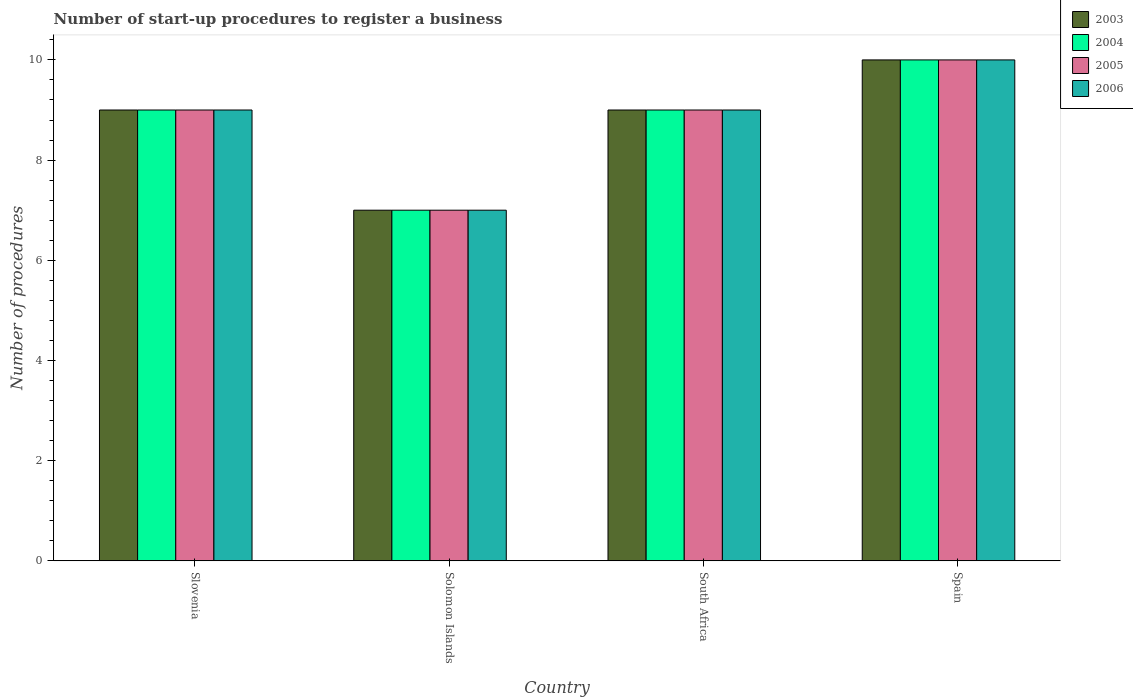How many different coloured bars are there?
Provide a succinct answer. 4. Are the number of bars per tick equal to the number of legend labels?
Your response must be concise. Yes. Are the number of bars on each tick of the X-axis equal?
Offer a terse response. Yes. How many bars are there on the 3rd tick from the left?
Your answer should be compact. 4. How many bars are there on the 2nd tick from the right?
Offer a very short reply. 4. What is the label of the 1st group of bars from the left?
Keep it short and to the point. Slovenia. In which country was the number of procedures required to register a business in 2003 maximum?
Provide a succinct answer. Spain. In which country was the number of procedures required to register a business in 2003 minimum?
Provide a short and direct response. Solomon Islands. What is the difference between the number of procedures required to register a business in 2005 in South Africa and the number of procedures required to register a business in 2006 in Solomon Islands?
Provide a succinct answer. 2. What is the average number of procedures required to register a business in 2004 per country?
Provide a succinct answer. 8.75. What is the difference between the number of procedures required to register a business of/in 2003 and number of procedures required to register a business of/in 2005 in South Africa?
Keep it short and to the point. 0. In how many countries, is the number of procedures required to register a business in 2006 greater than 7.6?
Provide a succinct answer. 3. What is the ratio of the number of procedures required to register a business in 2006 in Slovenia to that in South Africa?
Give a very brief answer. 1. Is the difference between the number of procedures required to register a business in 2003 in Slovenia and Spain greater than the difference between the number of procedures required to register a business in 2005 in Slovenia and Spain?
Your answer should be very brief. No. In how many countries, is the number of procedures required to register a business in 2004 greater than the average number of procedures required to register a business in 2004 taken over all countries?
Provide a succinct answer. 3. Is the sum of the number of procedures required to register a business in 2006 in Slovenia and South Africa greater than the maximum number of procedures required to register a business in 2003 across all countries?
Keep it short and to the point. Yes. What does the 3rd bar from the left in South Africa represents?
Offer a terse response. 2005. What does the 4th bar from the right in Solomon Islands represents?
Your response must be concise. 2003. Is it the case that in every country, the sum of the number of procedures required to register a business in 2005 and number of procedures required to register a business in 2003 is greater than the number of procedures required to register a business in 2004?
Your answer should be compact. Yes. How many bars are there?
Offer a very short reply. 16. Where does the legend appear in the graph?
Your response must be concise. Top right. How many legend labels are there?
Keep it short and to the point. 4. How are the legend labels stacked?
Give a very brief answer. Vertical. What is the title of the graph?
Your answer should be compact. Number of start-up procedures to register a business. Does "1969" appear as one of the legend labels in the graph?
Provide a succinct answer. No. What is the label or title of the X-axis?
Your answer should be compact. Country. What is the label or title of the Y-axis?
Offer a terse response. Number of procedures. What is the Number of procedures of 2003 in Slovenia?
Keep it short and to the point. 9. What is the Number of procedures of 2006 in Slovenia?
Offer a very short reply. 9. What is the Number of procedures of 2003 in Solomon Islands?
Your answer should be compact. 7. What is the Number of procedures in 2005 in Solomon Islands?
Offer a terse response. 7. What is the Number of procedures in 2005 in South Africa?
Offer a terse response. 9. What is the Number of procedures in 2006 in South Africa?
Your answer should be very brief. 9. What is the Number of procedures in 2004 in Spain?
Your response must be concise. 10. What is the Number of procedures in 2006 in Spain?
Offer a terse response. 10. Across all countries, what is the maximum Number of procedures of 2004?
Ensure brevity in your answer.  10. Across all countries, what is the maximum Number of procedures of 2005?
Make the answer very short. 10. Across all countries, what is the minimum Number of procedures in 2004?
Ensure brevity in your answer.  7. Across all countries, what is the minimum Number of procedures in 2005?
Your response must be concise. 7. What is the total Number of procedures in 2004 in the graph?
Keep it short and to the point. 35. What is the total Number of procedures of 2006 in the graph?
Make the answer very short. 35. What is the difference between the Number of procedures in 2004 in Slovenia and that in Solomon Islands?
Offer a terse response. 2. What is the difference between the Number of procedures of 2003 in Slovenia and that in South Africa?
Your answer should be compact. 0. What is the difference between the Number of procedures of 2006 in Slovenia and that in South Africa?
Give a very brief answer. 0. What is the difference between the Number of procedures in 2005 in Slovenia and that in Spain?
Your answer should be very brief. -1. What is the difference between the Number of procedures in 2003 in Solomon Islands and that in South Africa?
Your response must be concise. -2. What is the difference between the Number of procedures of 2004 in Solomon Islands and that in South Africa?
Provide a short and direct response. -2. What is the difference between the Number of procedures of 2005 in Solomon Islands and that in South Africa?
Your answer should be compact. -2. What is the difference between the Number of procedures in 2006 in Solomon Islands and that in South Africa?
Provide a succinct answer. -2. What is the difference between the Number of procedures of 2003 in Solomon Islands and that in Spain?
Keep it short and to the point. -3. What is the difference between the Number of procedures of 2005 in South Africa and that in Spain?
Keep it short and to the point. -1. What is the difference between the Number of procedures in 2006 in South Africa and that in Spain?
Give a very brief answer. -1. What is the difference between the Number of procedures of 2003 in Slovenia and the Number of procedures of 2004 in Solomon Islands?
Your response must be concise. 2. What is the difference between the Number of procedures in 2003 in Slovenia and the Number of procedures in 2005 in Solomon Islands?
Offer a terse response. 2. What is the difference between the Number of procedures of 2003 in Slovenia and the Number of procedures of 2006 in Solomon Islands?
Give a very brief answer. 2. What is the difference between the Number of procedures in 2004 in Slovenia and the Number of procedures in 2006 in Solomon Islands?
Give a very brief answer. 2. What is the difference between the Number of procedures of 2003 in Slovenia and the Number of procedures of 2004 in South Africa?
Offer a terse response. 0. What is the difference between the Number of procedures of 2003 in Slovenia and the Number of procedures of 2005 in South Africa?
Offer a very short reply. 0. What is the difference between the Number of procedures of 2004 in Slovenia and the Number of procedures of 2005 in South Africa?
Offer a very short reply. 0. What is the difference between the Number of procedures of 2003 in Slovenia and the Number of procedures of 2004 in Spain?
Give a very brief answer. -1. What is the difference between the Number of procedures of 2003 in Slovenia and the Number of procedures of 2006 in Spain?
Make the answer very short. -1. What is the difference between the Number of procedures in 2004 in Slovenia and the Number of procedures in 2006 in Spain?
Ensure brevity in your answer.  -1. What is the difference between the Number of procedures of 2005 in Slovenia and the Number of procedures of 2006 in Spain?
Your response must be concise. -1. What is the difference between the Number of procedures in 2004 in Solomon Islands and the Number of procedures in 2005 in South Africa?
Provide a short and direct response. -2. What is the difference between the Number of procedures of 2005 in Solomon Islands and the Number of procedures of 2006 in South Africa?
Offer a very short reply. -2. What is the difference between the Number of procedures of 2003 in Solomon Islands and the Number of procedures of 2006 in Spain?
Give a very brief answer. -3. What is the difference between the Number of procedures in 2004 in Solomon Islands and the Number of procedures in 2006 in Spain?
Ensure brevity in your answer.  -3. What is the difference between the Number of procedures in 2003 in South Africa and the Number of procedures in 2005 in Spain?
Your answer should be compact. -1. What is the difference between the Number of procedures in 2003 in South Africa and the Number of procedures in 2006 in Spain?
Your response must be concise. -1. What is the difference between the Number of procedures in 2005 in South Africa and the Number of procedures in 2006 in Spain?
Give a very brief answer. -1. What is the average Number of procedures of 2003 per country?
Offer a terse response. 8.75. What is the average Number of procedures in 2004 per country?
Offer a terse response. 8.75. What is the average Number of procedures of 2005 per country?
Make the answer very short. 8.75. What is the average Number of procedures in 2006 per country?
Offer a terse response. 8.75. What is the difference between the Number of procedures of 2004 and Number of procedures of 2006 in Slovenia?
Make the answer very short. 0. What is the difference between the Number of procedures in 2003 and Number of procedures in 2005 in Solomon Islands?
Your answer should be compact. 0. What is the difference between the Number of procedures in 2004 and Number of procedures in 2005 in Solomon Islands?
Offer a terse response. 0. What is the difference between the Number of procedures in 2004 and Number of procedures in 2006 in Solomon Islands?
Give a very brief answer. 0. What is the difference between the Number of procedures in 2005 and Number of procedures in 2006 in Solomon Islands?
Your response must be concise. 0. What is the difference between the Number of procedures in 2003 and Number of procedures in 2004 in South Africa?
Offer a terse response. 0. What is the difference between the Number of procedures in 2003 and Number of procedures in 2005 in South Africa?
Make the answer very short. 0. What is the difference between the Number of procedures of 2003 and Number of procedures of 2006 in South Africa?
Offer a very short reply. 0. What is the difference between the Number of procedures of 2005 and Number of procedures of 2006 in South Africa?
Provide a short and direct response. 0. What is the difference between the Number of procedures in 2003 and Number of procedures in 2006 in Spain?
Offer a very short reply. 0. What is the difference between the Number of procedures in 2004 and Number of procedures in 2005 in Spain?
Provide a succinct answer. 0. What is the ratio of the Number of procedures in 2004 in Slovenia to that in Solomon Islands?
Ensure brevity in your answer.  1.29. What is the ratio of the Number of procedures of 2003 in Slovenia to that in South Africa?
Keep it short and to the point. 1. What is the ratio of the Number of procedures of 2006 in Slovenia to that in South Africa?
Your answer should be very brief. 1. What is the ratio of the Number of procedures in 2004 in Slovenia to that in Spain?
Your answer should be compact. 0.9. What is the ratio of the Number of procedures in 2006 in Slovenia to that in Spain?
Provide a short and direct response. 0.9. What is the ratio of the Number of procedures in 2003 in Solomon Islands to that in South Africa?
Your response must be concise. 0.78. What is the ratio of the Number of procedures of 2004 in Solomon Islands to that in South Africa?
Ensure brevity in your answer.  0.78. What is the ratio of the Number of procedures of 2005 in Solomon Islands to that in South Africa?
Offer a very short reply. 0.78. What is the ratio of the Number of procedures in 2003 in Solomon Islands to that in Spain?
Make the answer very short. 0.7. What is the ratio of the Number of procedures of 2004 in Solomon Islands to that in Spain?
Offer a very short reply. 0.7. What is the ratio of the Number of procedures of 2005 in Solomon Islands to that in Spain?
Provide a short and direct response. 0.7. What is the ratio of the Number of procedures of 2003 in South Africa to that in Spain?
Your response must be concise. 0.9. What is the ratio of the Number of procedures in 2004 in South Africa to that in Spain?
Your response must be concise. 0.9. What is the ratio of the Number of procedures in 2005 in South Africa to that in Spain?
Offer a very short reply. 0.9. What is the ratio of the Number of procedures in 2006 in South Africa to that in Spain?
Your response must be concise. 0.9. What is the difference between the highest and the second highest Number of procedures of 2004?
Provide a short and direct response. 1. What is the difference between the highest and the second highest Number of procedures of 2005?
Keep it short and to the point. 1. What is the difference between the highest and the lowest Number of procedures in 2003?
Keep it short and to the point. 3. What is the difference between the highest and the lowest Number of procedures of 2006?
Provide a short and direct response. 3. 